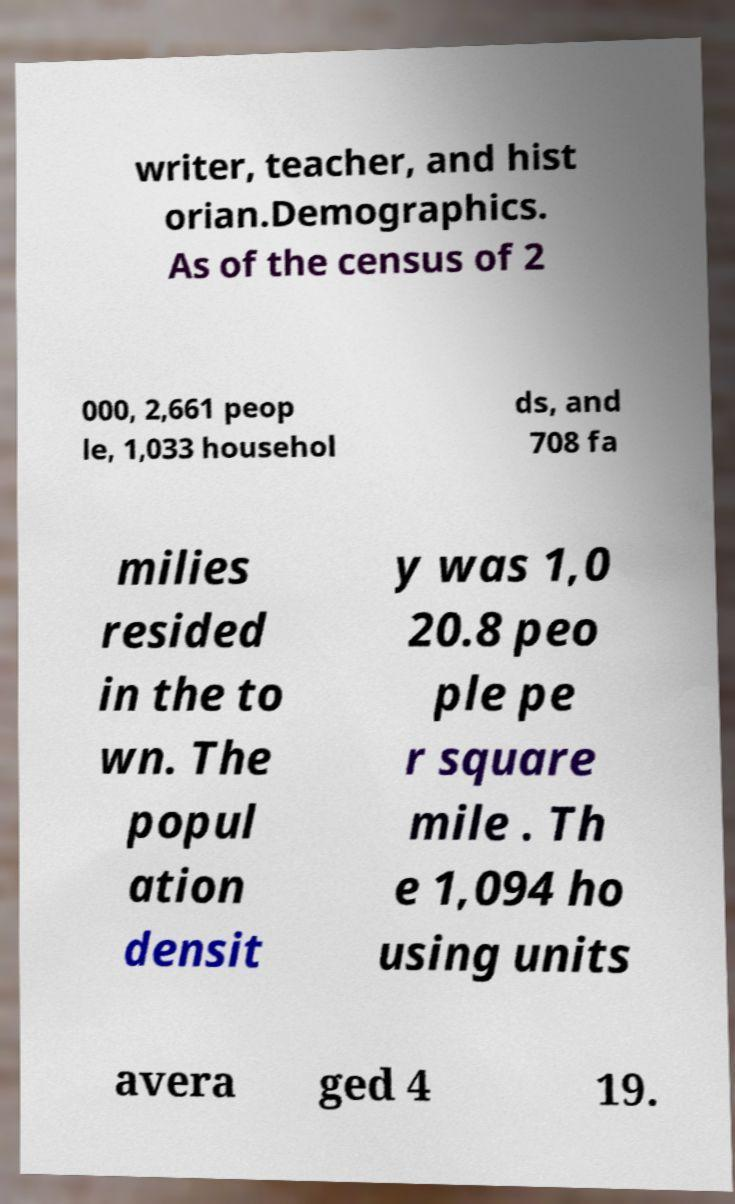For documentation purposes, I need the text within this image transcribed. Could you provide that? writer, teacher, and hist orian.Demographics. As of the census of 2 000, 2,661 peop le, 1,033 househol ds, and 708 fa milies resided in the to wn. The popul ation densit y was 1,0 20.8 peo ple pe r square mile . Th e 1,094 ho using units avera ged 4 19. 